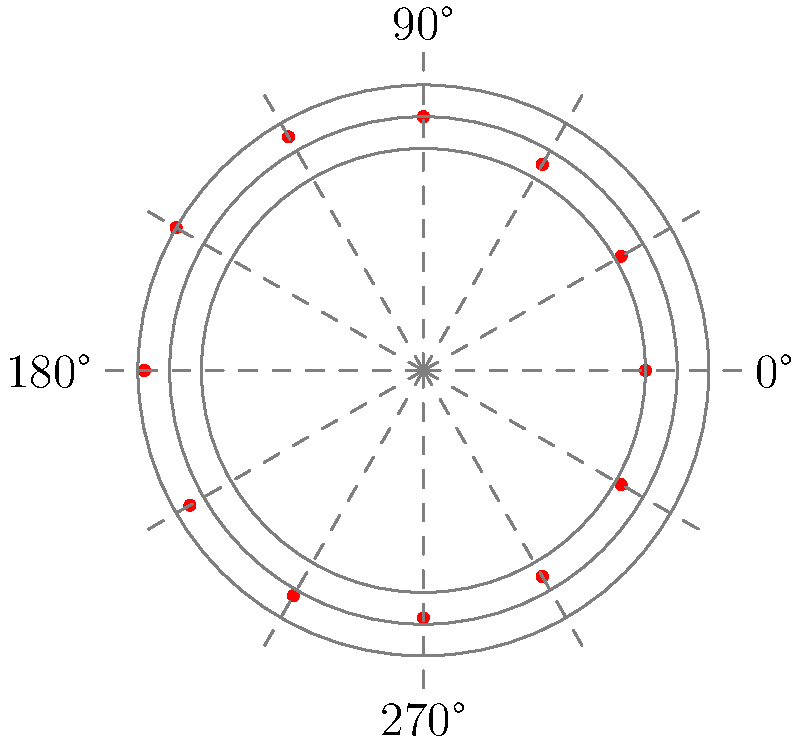In the polar plot above, heart rate measurements are taken every 30 minutes over a 6-hour period. What is the maximum heart rate recorded, and at approximately what time does it occur relative to the start of monitoring? To solve this question, we need to follow these steps:

1. Understand the plot:
   - The radial distance from the center represents the heart rate.
   - The angular position represents time, with 0° being the start of monitoring.
   - Each 30° increment represents 30 minutes.

2. Identify the maximum heart rate:
   - Visually inspect the plot to find the point farthest from the center.
   - This point appears to be at the 90 bpm circle.

3. Determine the time of the maximum heart rate:
   - The maximum point is located at approximately 150° from the 0° line.
   - Calculate the time: $\frac{150°}{30° \text{ per 30 minutes}} \times 30 \text{ minutes} = 150 \text{ minutes}$
   - Convert to hours: $150 \text{ minutes} = 2.5 \text{ hours}$

Therefore, the maximum heart rate is 90 bpm, occurring approximately 2.5 hours after the start of monitoring.
Answer: 90 bpm, 2.5 hours 